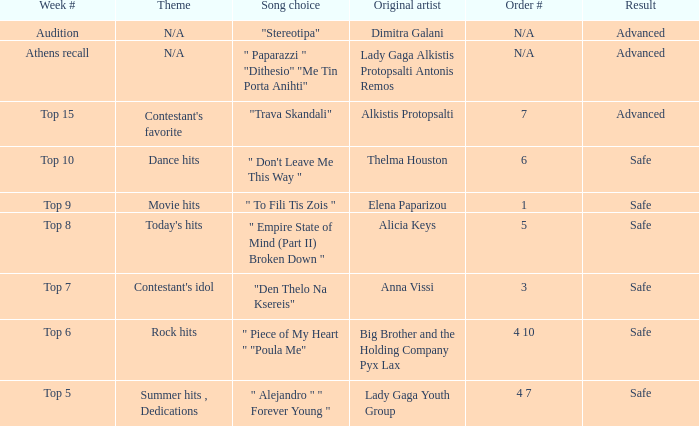Can you identify the artists with order number 6? Thelma Houston. 